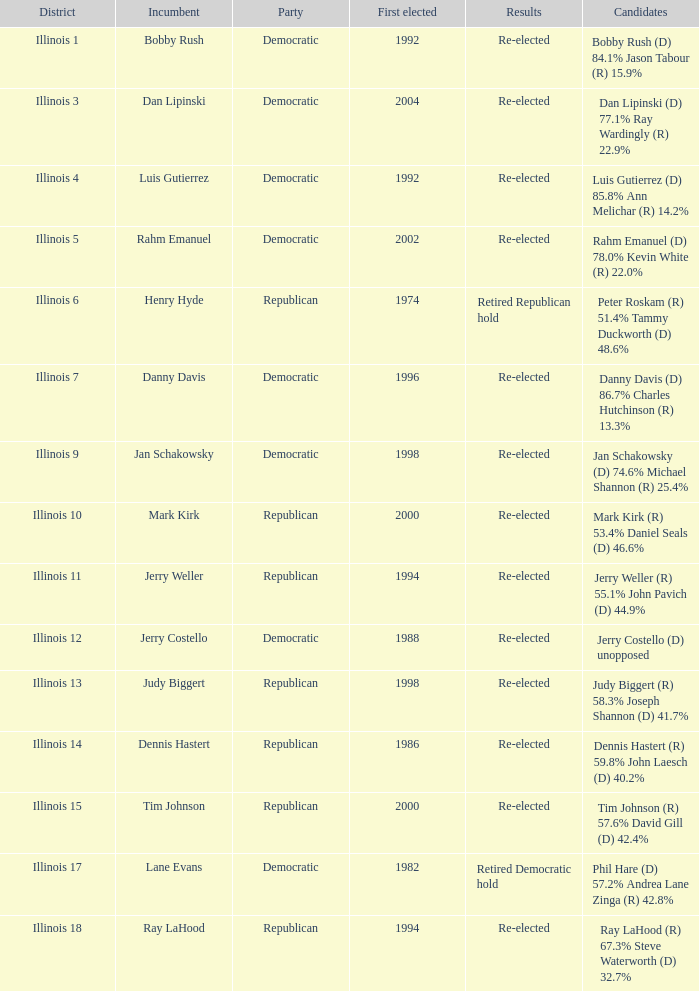Who were the candidates when the first elected was a republican in 1998?  Judy Biggert (R) 58.3% Joseph Shannon (D) 41.7%. 